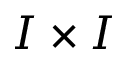Convert formula to latex. <formula><loc_0><loc_0><loc_500><loc_500>I \times I</formula> 